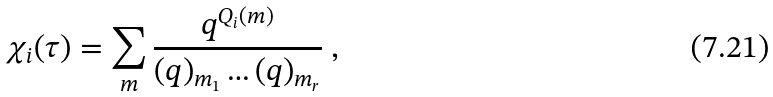Convert formula to latex. <formula><loc_0><loc_0><loc_500><loc_500>\chi _ { i } ( \tau ) = \sum _ { m } \frac { q ^ { Q _ { i } ( m ) } } { ( q ) _ { m _ { 1 } } \dots ( q ) _ { m _ { r } } } \ ,</formula> 